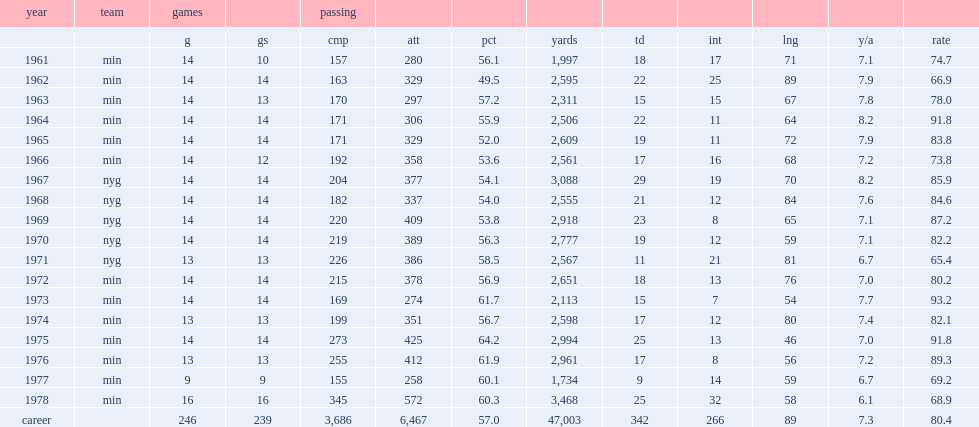How many passing yards did fran tarkenton get in 1961? 1997.0. 